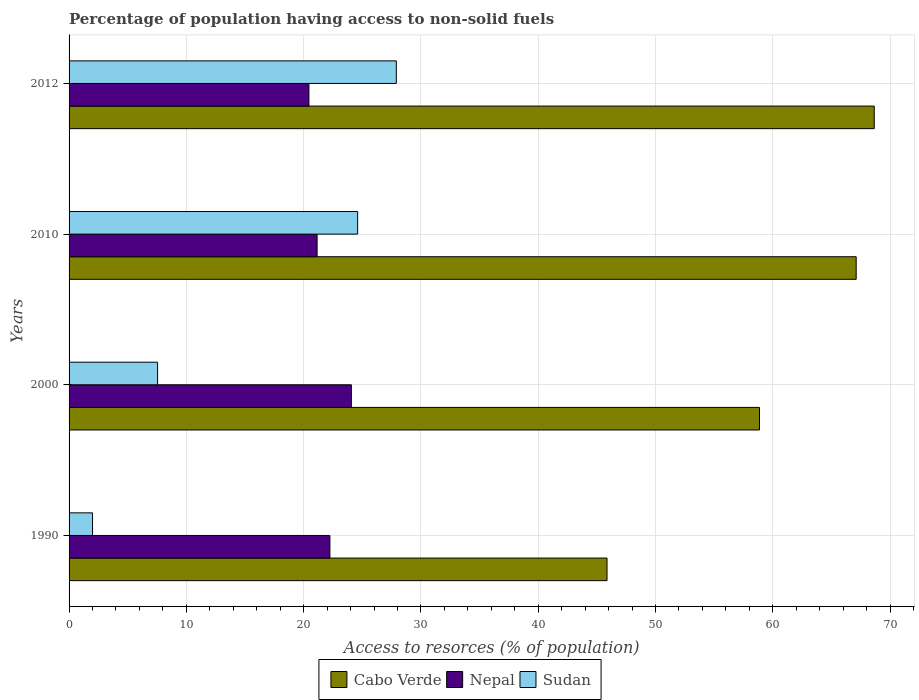Are the number of bars per tick equal to the number of legend labels?
Give a very brief answer. Yes. How many bars are there on the 1st tick from the top?
Your answer should be very brief. 3. In how many cases, is the number of bars for a given year not equal to the number of legend labels?
Your answer should be compact. 0. What is the percentage of population having access to non-solid fuels in Sudan in 2010?
Your answer should be very brief. 24.6. Across all years, what is the maximum percentage of population having access to non-solid fuels in Sudan?
Your answer should be very brief. 27.9. Across all years, what is the minimum percentage of population having access to non-solid fuels in Nepal?
Offer a terse response. 20.45. In which year was the percentage of population having access to non-solid fuels in Cabo Verde maximum?
Give a very brief answer. 2012. What is the total percentage of population having access to non-solid fuels in Sudan in the graph?
Offer a very short reply. 62.06. What is the difference between the percentage of population having access to non-solid fuels in Nepal in 2010 and that in 2012?
Offer a terse response. 0.7. What is the difference between the percentage of population having access to non-solid fuels in Cabo Verde in 2010 and the percentage of population having access to non-solid fuels in Sudan in 2000?
Provide a succinct answer. 59.57. What is the average percentage of population having access to non-solid fuels in Nepal per year?
Keep it short and to the point. 21.98. In the year 2000, what is the difference between the percentage of population having access to non-solid fuels in Cabo Verde and percentage of population having access to non-solid fuels in Nepal?
Your answer should be compact. 34.8. In how many years, is the percentage of population having access to non-solid fuels in Cabo Verde greater than 24 %?
Offer a very short reply. 4. What is the ratio of the percentage of population having access to non-solid fuels in Cabo Verde in 1990 to that in 2010?
Your answer should be compact. 0.68. Is the percentage of population having access to non-solid fuels in Cabo Verde in 2000 less than that in 2012?
Offer a very short reply. Yes. Is the difference between the percentage of population having access to non-solid fuels in Cabo Verde in 2000 and 2012 greater than the difference between the percentage of population having access to non-solid fuels in Nepal in 2000 and 2012?
Your answer should be very brief. No. What is the difference between the highest and the second highest percentage of population having access to non-solid fuels in Sudan?
Provide a succinct answer. 3.3. What is the difference between the highest and the lowest percentage of population having access to non-solid fuels in Sudan?
Your answer should be very brief. 25.9. In how many years, is the percentage of population having access to non-solid fuels in Cabo Verde greater than the average percentage of population having access to non-solid fuels in Cabo Verde taken over all years?
Your answer should be compact. 2. What does the 2nd bar from the top in 2012 represents?
Your response must be concise. Nepal. What does the 1st bar from the bottom in 1990 represents?
Ensure brevity in your answer.  Cabo Verde. Is it the case that in every year, the sum of the percentage of population having access to non-solid fuels in Sudan and percentage of population having access to non-solid fuels in Cabo Verde is greater than the percentage of population having access to non-solid fuels in Nepal?
Your response must be concise. Yes. How many bars are there?
Provide a succinct answer. 12. Are all the bars in the graph horizontal?
Offer a very short reply. Yes. What is the difference between two consecutive major ticks on the X-axis?
Offer a very short reply. 10. Are the values on the major ticks of X-axis written in scientific E-notation?
Provide a short and direct response. No. Does the graph contain any zero values?
Provide a short and direct response. No. How many legend labels are there?
Provide a succinct answer. 3. What is the title of the graph?
Keep it short and to the point. Percentage of population having access to non-solid fuels. Does "Other small states" appear as one of the legend labels in the graph?
Offer a terse response. No. What is the label or title of the X-axis?
Keep it short and to the point. Access to resorces (% of population). What is the Access to resorces (% of population) of Cabo Verde in 1990?
Your response must be concise. 45.87. What is the Access to resorces (% of population) in Nepal in 1990?
Your answer should be very brief. 22.24. What is the Access to resorces (% of population) of Sudan in 1990?
Ensure brevity in your answer.  2. What is the Access to resorces (% of population) of Cabo Verde in 2000?
Offer a very short reply. 58.87. What is the Access to resorces (% of population) of Nepal in 2000?
Your answer should be compact. 24.07. What is the Access to resorces (% of population) of Sudan in 2000?
Provide a succinct answer. 7.55. What is the Access to resorces (% of population) of Cabo Verde in 2010?
Your response must be concise. 67.11. What is the Access to resorces (% of population) in Nepal in 2010?
Give a very brief answer. 21.15. What is the Access to resorces (% of population) in Sudan in 2010?
Offer a very short reply. 24.6. What is the Access to resorces (% of population) of Cabo Verde in 2012?
Offer a very short reply. 68.65. What is the Access to resorces (% of population) in Nepal in 2012?
Offer a very short reply. 20.45. What is the Access to resorces (% of population) in Sudan in 2012?
Give a very brief answer. 27.9. Across all years, what is the maximum Access to resorces (% of population) in Cabo Verde?
Keep it short and to the point. 68.65. Across all years, what is the maximum Access to resorces (% of population) of Nepal?
Your response must be concise. 24.07. Across all years, what is the maximum Access to resorces (% of population) of Sudan?
Give a very brief answer. 27.9. Across all years, what is the minimum Access to resorces (% of population) in Cabo Verde?
Make the answer very short. 45.87. Across all years, what is the minimum Access to resorces (% of population) of Nepal?
Your answer should be compact. 20.45. Across all years, what is the minimum Access to resorces (% of population) of Sudan?
Give a very brief answer. 2. What is the total Access to resorces (% of population) in Cabo Verde in the graph?
Provide a short and direct response. 240.51. What is the total Access to resorces (% of population) in Nepal in the graph?
Give a very brief answer. 87.91. What is the total Access to resorces (% of population) in Sudan in the graph?
Offer a terse response. 62.06. What is the difference between the Access to resorces (% of population) in Cabo Verde in 1990 and that in 2000?
Give a very brief answer. -13. What is the difference between the Access to resorces (% of population) in Nepal in 1990 and that in 2000?
Provide a succinct answer. -1.83. What is the difference between the Access to resorces (% of population) in Sudan in 1990 and that in 2000?
Provide a short and direct response. -5.55. What is the difference between the Access to resorces (% of population) of Cabo Verde in 1990 and that in 2010?
Offer a terse response. -21.24. What is the difference between the Access to resorces (% of population) in Nepal in 1990 and that in 2010?
Provide a succinct answer. 1.09. What is the difference between the Access to resorces (% of population) of Sudan in 1990 and that in 2010?
Ensure brevity in your answer.  -22.6. What is the difference between the Access to resorces (% of population) of Cabo Verde in 1990 and that in 2012?
Provide a short and direct response. -22.78. What is the difference between the Access to resorces (% of population) in Nepal in 1990 and that in 2012?
Offer a very short reply. 1.79. What is the difference between the Access to resorces (% of population) of Sudan in 1990 and that in 2012?
Provide a succinct answer. -25.9. What is the difference between the Access to resorces (% of population) of Cabo Verde in 2000 and that in 2010?
Keep it short and to the point. -8.25. What is the difference between the Access to resorces (% of population) in Nepal in 2000 and that in 2010?
Keep it short and to the point. 2.92. What is the difference between the Access to resorces (% of population) of Sudan in 2000 and that in 2010?
Offer a very short reply. -17.06. What is the difference between the Access to resorces (% of population) of Cabo Verde in 2000 and that in 2012?
Keep it short and to the point. -9.79. What is the difference between the Access to resorces (% of population) in Nepal in 2000 and that in 2012?
Your response must be concise. 3.62. What is the difference between the Access to resorces (% of population) in Sudan in 2000 and that in 2012?
Provide a succinct answer. -20.36. What is the difference between the Access to resorces (% of population) of Cabo Verde in 2010 and that in 2012?
Ensure brevity in your answer.  -1.54. What is the difference between the Access to resorces (% of population) in Nepal in 2010 and that in 2012?
Ensure brevity in your answer.  0.7. What is the difference between the Access to resorces (% of population) in Sudan in 2010 and that in 2012?
Give a very brief answer. -3.3. What is the difference between the Access to resorces (% of population) in Cabo Verde in 1990 and the Access to resorces (% of population) in Nepal in 2000?
Ensure brevity in your answer.  21.8. What is the difference between the Access to resorces (% of population) in Cabo Verde in 1990 and the Access to resorces (% of population) in Sudan in 2000?
Provide a short and direct response. 38.32. What is the difference between the Access to resorces (% of population) of Nepal in 1990 and the Access to resorces (% of population) of Sudan in 2000?
Provide a succinct answer. 14.69. What is the difference between the Access to resorces (% of population) of Cabo Verde in 1990 and the Access to resorces (% of population) of Nepal in 2010?
Provide a succinct answer. 24.72. What is the difference between the Access to resorces (% of population) of Cabo Verde in 1990 and the Access to resorces (% of population) of Sudan in 2010?
Keep it short and to the point. 21.27. What is the difference between the Access to resorces (% of population) of Nepal in 1990 and the Access to resorces (% of population) of Sudan in 2010?
Give a very brief answer. -2.36. What is the difference between the Access to resorces (% of population) in Cabo Verde in 1990 and the Access to resorces (% of population) in Nepal in 2012?
Your response must be concise. 25.42. What is the difference between the Access to resorces (% of population) of Cabo Verde in 1990 and the Access to resorces (% of population) of Sudan in 2012?
Keep it short and to the point. 17.97. What is the difference between the Access to resorces (% of population) of Nepal in 1990 and the Access to resorces (% of population) of Sudan in 2012?
Offer a very short reply. -5.66. What is the difference between the Access to resorces (% of population) in Cabo Verde in 2000 and the Access to resorces (% of population) in Nepal in 2010?
Keep it short and to the point. 37.72. What is the difference between the Access to resorces (% of population) in Cabo Verde in 2000 and the Access to resorces (% of population) in Sudan in 2010?
Your response must be concise. 34.26. What is the difference between the Access to resorces (% of population) in Nepal in 2000 and the Access to resorces (% of population) in Sudan in 2010?
Give a very brief answer. -0.53. What is the difference between the Access to resorces (% of population) in Cabo Verde in 2000 and the Access to resorces (% of population) in Nepal in 2012?
Your response must be concise. 38.42. What is the difference between the Access to resorces (% of population) of Cabo Verde in 2000 and the Access to resorces (% of population) of Sudan in 2012?
Make the answer very short. 30.96. What is the difference between the Access to resorces (% of population) of Nepal in 2000 and the Access to resorces (% of population) of Sudan in 2012?
Make the answer very short. -3.83. What is the difference between the Access to resorces (% of population) of Cabo Verde in 2010 and the Access to resorces (% of population) of Nepal in 2012?
Give a very brief answer. 46.66. What is the difference between the Access to resorces (% of population) of Cabo Verde in 2010 and the Access to resorces (% of population) of Sudan in 2012?
Keep it short and to the point. 39.21. What is the difference between the Access to resorces (% of population) of Nepal in 2010 and the Access to resorces (% of population) of Sudan in 2012?
Your answer should be very brief. -6.76. What is the average Access to resorces (% of population) of Cabo Verde per year?
Your response must be concise. 60.13. What is the average Access to resorces (% of population) of Nepal per year?
Give a very brief answer. 21.98. What is the average Access to resorces (% of population) in Sudan per year?
Your answer should be very brief. 15.51. In the year 1990, what is the difference between the Access to resorces (% of population) in Cabo Verde and Access to resorces (% of population) in Nepal?
Your answer should be very brief. 23.63. In the year 1990, what is the difference between the Access to resorces (% of population) of Cabo Verde and Access to resorces (% of population) of Sudan?
Your answer should be very brief. 43.87. In the year 1990, what is the difference between the Access to resorces (% of population) in Nepal and Access to resorces (% of population) in Sudan?
Offer a very short reply. 20.24. In the year 2000, what is the difference between the Access to resorces (% of population) in Cabo Verde and Access to resorces (% of population) in Nepal?
Give a very brief answer. 34.8. In the year 2000, what is the difference between the Access to resorces (% of population) of Cabo Verde and Access to resorces (% of population) of Sudan?
Provide a short and direct response. 51.32. In the year 2000, what is the difference between the Access to resorces (% of population) of Nepal and Access to resorces (% of population) of Sudan?
Provide a short and direct response. 16.52. In the year 2010, what is the difference between the Access to resorces (% of population) in Cabo Verde and Access to resorces (% of population) in Nepal?
Keep it short and to the point. 45.97. In the year 2010, what is the difference between the Access to resorces (% of population) of Cabo Verde and Access to resorces (% of population) of Sudan?
Your answer should be compact. 42.51. In the year 2010, what is the difference between the Access to resorces (% of population) of Nepal and Access to resorces (% of population) of Sudan?
Make the answer very short. -3.46. In the year 2012, what is the difference between the Access to resorces (% of population) in Cabo Verde and Access to resorces (% of population) in Nepal?
Your answer should be compact. 48.2. In the year 2012, what is the difference between the Access to resorces (% of population) in Cabo Verde and Access to resorces (% of population) in Sudan?
Provide a short and direct response. 40.75. In the year 2012, what is the difference between the Access to resorces (% of population) in Nepal and Access to resorces (% of population) in Sudan?
Keep it short and to the point. -7.45. What is the ratio of the Access to resorces (% of population) in Cabo Verde in 1990 to that in 2000?
Keep it short and to the point. 0.78. What is the ratio of the Access to resorces (% of population) of Nepal in 1990 to that in 2000?
Give a very brief answer. 0.92. What is the ratio of the Access to resorces (% of population) of Sudan in 1990 to that in 2000?
Ensure brevity in your answer.  0.27. What is the ratio of the Access to resorces (% of population) in Cabo Verde in 1990 to that in 2010?
Your response must be concise. 0.68. What is the ratio of the Access to resorces (% of population) of Nepal in 1990 to that in 2010?
Ensure brevity in your answer.  1.05. What is the ratio of the Access to resorces (% of population) in Sudan in 1990 to that in 2010?
Keep it short and to the point. 0.08. What is the ratio of the Access to resorces (% of population) of Cabo Verde in 1990 to that in 2012?
Ensure brevity in your answer.  0.67. What is the ratio of the Access to resorces (% of population) of Nepal in 1990 to that in 2012?
Offer a terse response. 1.09. What is the ratio of the Access to resorces (% of population) of Sudan in 1990 to that in 2012?
Your answer should be very brief. 0.07. What is the ratio of the Access to resorces (% of population) in Cabo Verde in 2000 to that in 2010?
Offer a very short reply. 0.88. What is the ratio of the Access to resorces (% of population) of Nepal in 2000 to that in 2010?
Your response must be concise. 1.14. What is the ratio of the Access to resorces (% of population) of Sudan in 2000 to that in 2010?
Ensure brevity in your answer.  0.31. What is the ratio of the Access to resorces (% of population) of Cabo Verde in 2000 to that in 2012?
Your answer should be compact. 0.86. What is the ratio of the Access to resorces (% of population) in Nepal in 2000 to that in 2012?
Keep it short and to the point. 1.18. What is the ratio of the Access to resorces (% of population) in Sudan in 2000 to that in 2012?
Offer a terse response. 0.27. What is the ratio of the Access to resorces (% of population) in Cabo Verde in 2010 to that in 2012?
Offer a terse response. 0.98. What is the ratio of the Access to resorces (% of population) in Nepal in 2010 to that in 2012?
Offer a very short reply. 1.03. What is the ratio of the Access to resorces (% of population) of Sudan in 2010 to that in 2012?
Your response must be concise. 0.88. What is the difference between the highest and the second highest Access to resorces (% of population) of Cabo Verde?
Offer a very short reply. 1.54. What is the difference between the highest and the second highest Access to resorces (% of population) of Nepal?
Provide a succinct answer. 1.83. What is the difference between the highest and the second highest Access to resorces (% of population) of Sudan?
Provide a succinct answer. 3.3. What is the difference between the highest and the lowest Access to resorces (% of population) of Cabo Verde?
Provide a short and direct response. 22.78. What is the difference between the highest and the lowest Access to resorces (% of population) in Nepal?
Your response must be concise. 3.62. What is the difference between the highest and the lowest Access to resorces (% of population) of Sudan?
Make the answer very short. 25.9. 